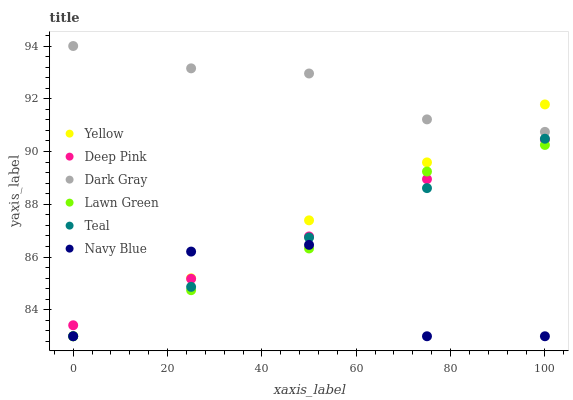Does Navy Blue have the minimum area under the curve?
Answer yes or no. Yes. Does Dark Gray have the maximum area under the curve?
Answer yes or no. Yes. Does Deep Pink have the minimum area under the curve?
Answer yes or no. No. Does Deep Pink have the maximum area under the curve?
Answer yes or no. No. Is Yellow the smoothest?
Answer yes or no. Yes. Is Navy Blue the roughest?
Answer yes or no. Yes. Is Deep Pink the smoothest?
Answer yes or no. No. Is Deep Pink the roughest?
Answer yes or no. No. Does Lawn Green have the lowest value?
Answer yes or no. Yes. Does Deep Pink have the lowest value?
Answer yes or no. No. Does Dark Gray have the highest value?
Answer yes or no. Yes. Does Deep Pink have the highest value?
Answer yes or no. No. Is Navy Blue less than Dark Gray?
Answer yes or no. Yes. Is Dark Gray greater than Deep Pink?
Answer yes or no. Yes. Does Yellow intersect Deep Pink?
Answer yes or no. Yes. Is Yellow less than Deep Pink?
Answer yes or no. No. Is Yellow greater than Deep Pink?
Answer yes or no. No. Does Navy Blue intersect Dark Gray?
Answer yes or no. No. 